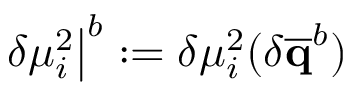Convert formula to latex. <formula><loc_0><loc_0><loc_500><loc_500>\delta \mu _ { i } ^ { 2 } \right | ^ { b } \colon = \delta \mu _ { i } ^ { 2 } ( \delta \overline { q } ^ { b } )</formula> 